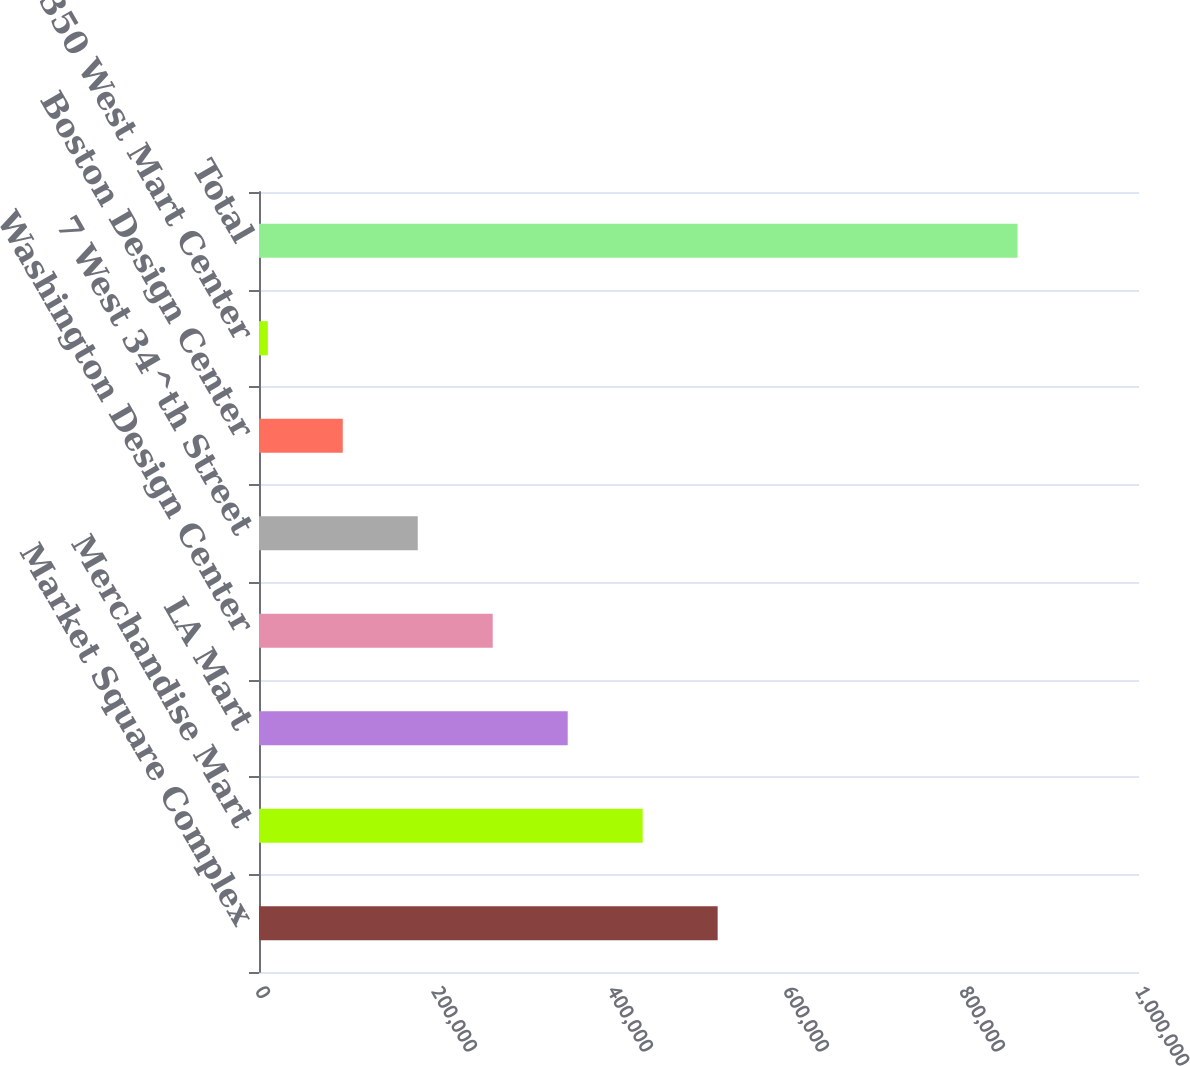<chart> <loc_0><loc_0><loc_500><loc_500><bar_chart><fcel>Market Square Complex<fcel>Merchandise Mart<fcel>LA Mart<fcel>Washington Design Center<fcel>7 West 34^th Street<fcel>Boston Design Center<fcel>350 West Mart Center<fcel>Total<nl><fcel>521200<fcel>436000<fcel>350800<fcel>265600<fcel>180400<fcel>95200<fcel>10000<fcel>862000<nl></chart> 